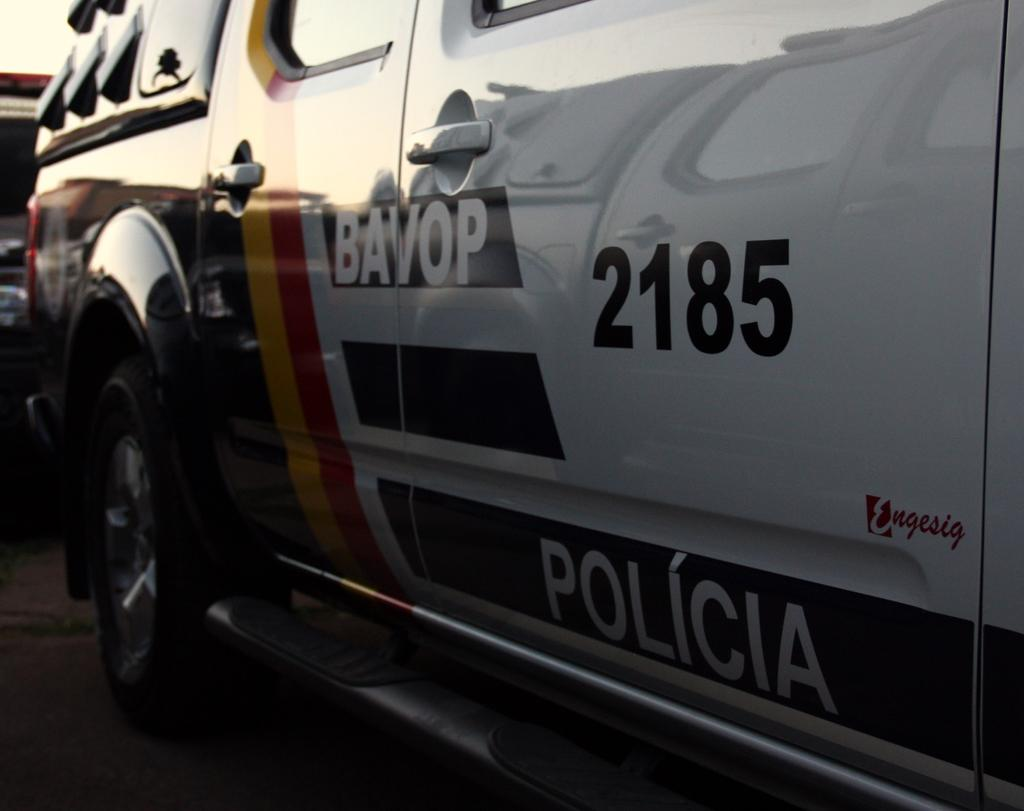What is happening in the image involving vehicles? There are vehicles on a path in the image. What else can be seen in the image besides the vehicles? There is text, numbers, and glass objects visible in the image. Can you describe the text or numbers in the image? Unfortunately, the specific text or numbers cannot be determined from the provided facts. What additional items or features can be seen on a vehicle in the image? There are additional items or features on a vehicle in the image, but their specific nature cannot be determined from the provided facts. What type of coat is hanging on the tree in the image? There is no tree or coat present in the image. What is the base of the structure supporting the vehicles in the image? There is no structure supporting the vehicles mentioned in the provided facts, so it is not possible to determine the base. 